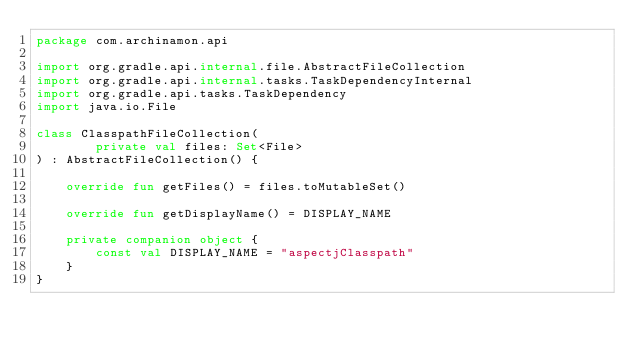<code> <loc_0><loc_0><loc_500><loc_500><_Kotlin_>package com.archinamon.api

import org.gradle.api.internal.file.AbstractFileCollection
import org.gradle.api.internal.tasks.TaskDependencyInternal
import org.gradle.api.tasks.TaskDependency
import java.io.File

class ClasspathFileCollection(
        private val files: Set<File>
) : AbstractFileCollection() {

    override fun getFiles() = files.toMutableSet()

    override fun getDisplayName() = DISPLAY_NAME

    private companion object {
        const val DISPLAY_NAME = "aspectjClasspath"
    }
}</code> 